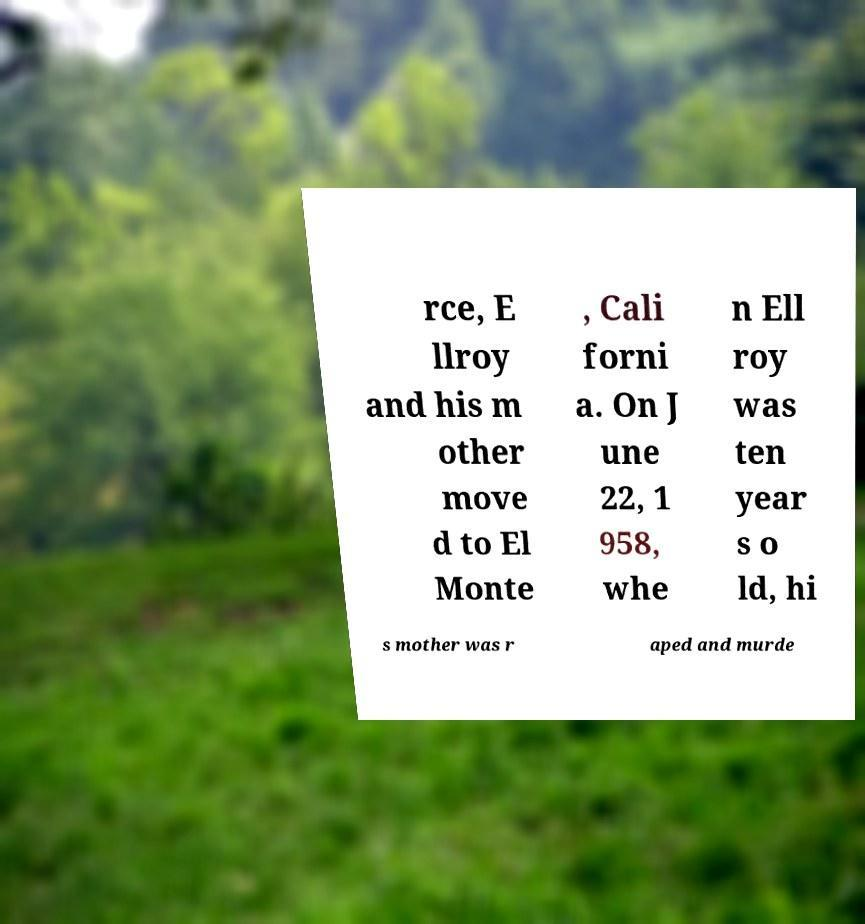Please read and relay the text visible in this image. What does it say? rce, E llroy and his m other move d to El Monte , Cali forni a. On J une 22, 1 958, whe n Ell roy was ten year s o ld, hi s mother was r aped and murde 